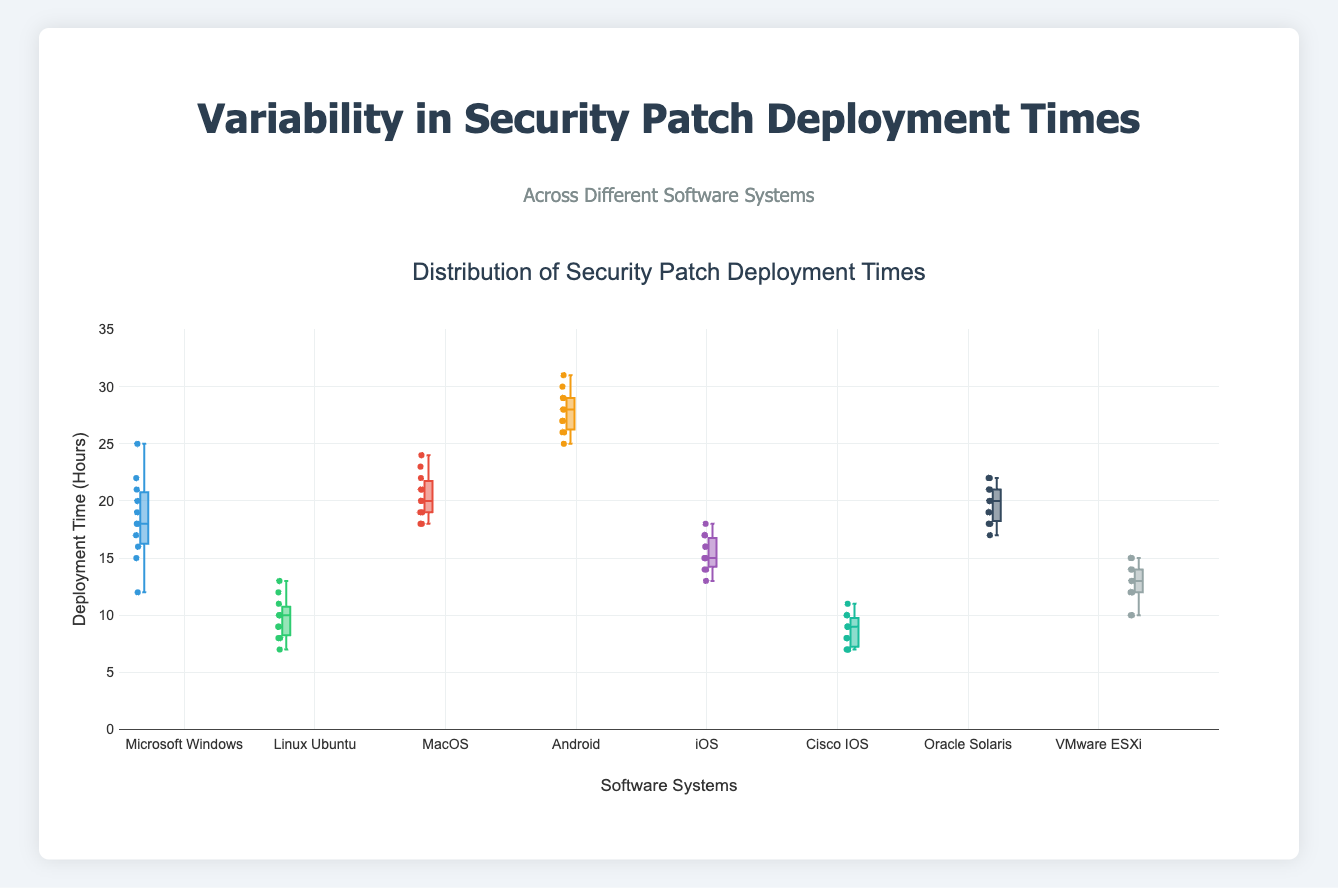What is the title of the figure? The title of the figure is displayed at the top, above the box plots.
Answer: Distribution of Security Patch Deployment Times Which software system has the highest median deployment time? The median is represented by the line in the middle of each box. The box for Android has the highest median line.
Answer: Android What is the range of deployment times for Cisco IOS? The range of a box plot is determined by the whiskers, which extend from the smallest to the largest value. For Cisco IOS, the smallest value is 7, and the largest is 11.
Answer: 7 to 11 How many software systems have deployment times with outliers? Outliers in a box plot are points that are outside the whiskers. For Microsoft Windows, Linux Ubuntu, and MacOS, we see individual points outside the whiskers.
Answer: 3 Which software system has the smallest interquartile range (IQR)? The IQR is the range between the first quartile (bottom of the box) and the third quartile (top of the box). Cisco IOS has the smallest distance between the top and bottom of the box.
Answer: Cisco IOS Compare the deployment times of Microsoft Windows and iOS. Which one has a larger spread? The spread of a dataset in a box plot can be determined by the length of the whiskers and the box. Microsoft Windows has longer whiskers and a larger box than iOS, indicating a larger spread.
Answer: Microsoft Windows What is the median deployment time for VMware ESXi, and how does it compare with Oracle Solaris? The median is indicated by the line inside each box. For VMware ESXi, the median is at 12. For Oracle Solaris, it is around 20. VMware ESXi's median is lower compared to Oracle Solaris.
Answer: VMware ESXi: 12, Oracle Solaris: 20 Which software system has the lowest minimum deployment time, and what is that time? The minimum deployment time is indicated by the lowest point of the whiskers. Cisco IOS has the lowest minimum time at 7 hours.
Answer: Cisco IOS, 7 hours What is the upper quartile (Q3) of MacOS deployment times? The upper quartile (or third quartile, Q3) is the top of the box for each software system. For MacOS, the upper quartile is at 22 hours.
Answer: 22 hours Which software system's deployment times are most consistent and why? Consistency in deployment times is indicated by a smaller interquartile range (IQR) and shorter whiskers. Cisco IOS has the smallest IQR and relatively short whiskers, indicating the most consistent deployment times.
Answer: Cisco IOS 